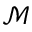<formula> <loc_0><loc_0><loc_500><loc_500>\mathcal { M }</formula> 